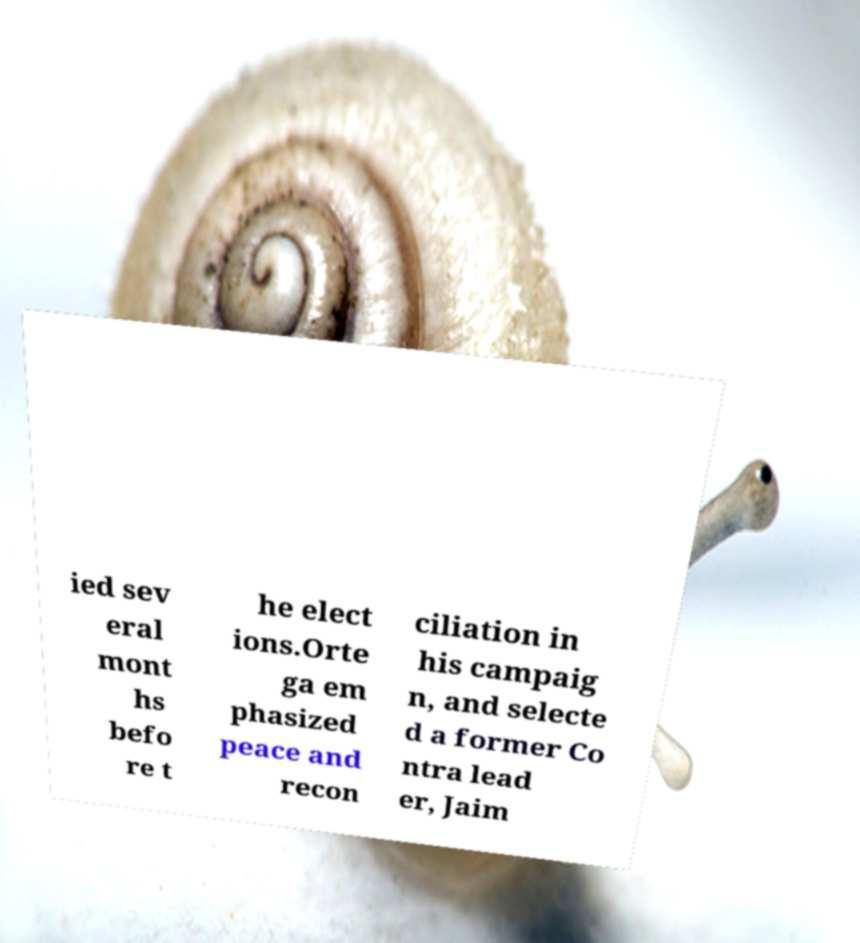There's text embedded in this image that I need extracted. Can you transcribe it verbatim? ied sev eral mont hs befo re t he elect ions.Orte ga em phasized peace and recon ciliation in his campaig n, and selecte d a former Co ntra lead er, Jaim 